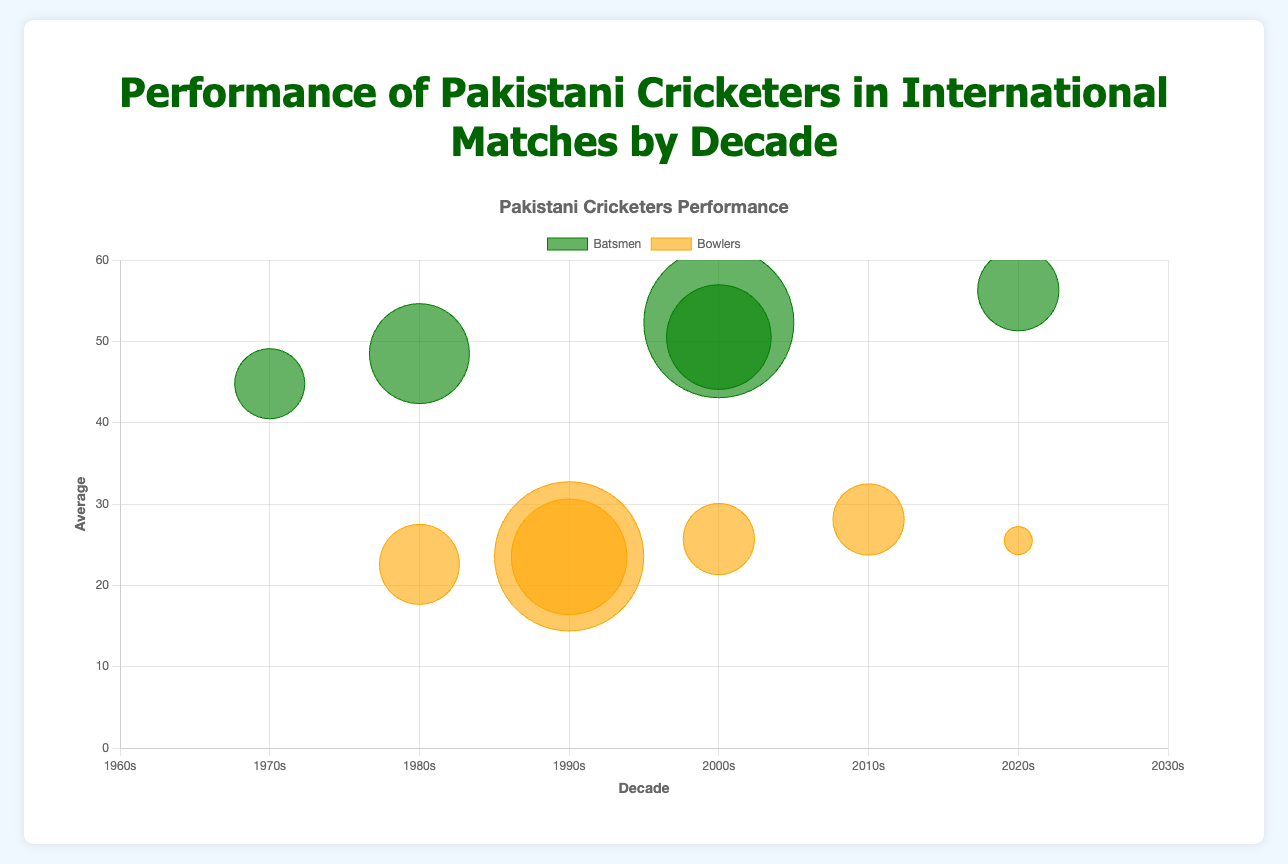How many players represented the 2000s decade? Count the number of data points for batsmen and bowlers in the 2000s decade. There are three players: Inzamam-ul-Haq, Younis Khan, and Shoaib Akhtar.
Answer: 3 Which bowler had the best average in the 1990s? Locate the bowlers from the 1990s decade and compare their averages. Wasim Akram had an average of 23.50 and Waqar Younis had 23.56. Wasim Akram had the better average.
Answer: Wasim Akram What is the highest batting average displayed on the bubble chart? Examine the y-axis values for the batsmen data points. The highest value corresponds to Babar Azam in the 2020s with an average of 56.29.
Answer: 56.29 Which batsman scored the most runs in the 2000s decade? Look at the data points for batsmen in the 2000s decade and check their runs. Younis Khan scored 7500 runs, which is more than Inzamam-ul-Haq's 5232 runs.
Answer: Younis Khan Compare the number of matches played by Wasim Akram and Shoaib Akhtar. Who played more, and by how many matches? Wasim Akram played 104 matches, while Shoaib Akhtar played 46 matches. 104 - 46 equals 58, so Wasim Akram played 58 more matches.
Answer: Wasim Akram, 58 Which player had the lowest bowling average in the chart? Examine the y-axis values for the bowlers' data points. Imran Khan in the 1980s had an average of 22.58, the lowest among bowlers.
Answer: Imran Khan Find the player with the smallest bubble (least wickets) in the 2020s decade and identify the player. Check the size (radius) of the bubbles for bowlers in the 2020s decade. Shaheen Afridi has a bubble corresponding to 70 wickets.
Answer: Shaheen Afridi Between Javed Miandad and Inzamam-ul-Haq, who had the higher batting average? Compare the y-axis values for Javed Miandad (48.49) and Inzamam-ul-Haq (50.52). Inzamam-ul-Haq had a higher batting average.
Answer: Inzamam-ul-Haq Which decade has the most players represented on the chart? Count the number of data points for each decade. The 2000s decade has the most players with three: Inzamam-ul-Haq, Younis Khan, and Shoaib Akhtar.
Answer: 2000s 